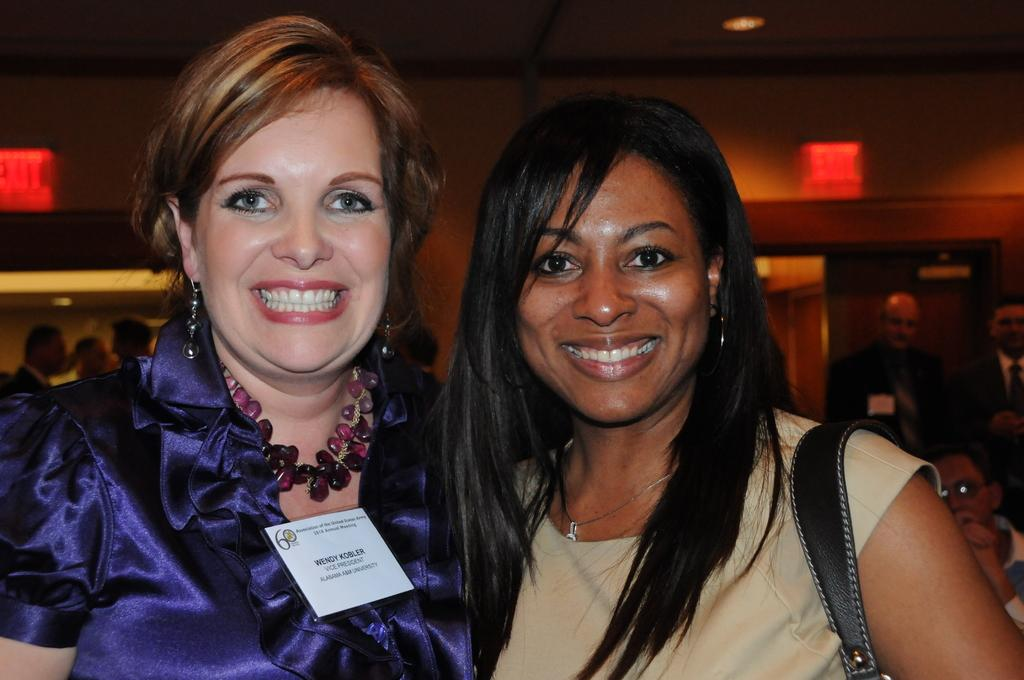How many women are in the image? There are two women in the image. What are the women doing in the image? The women are smiling and posing for the camera. Can you describe the people in the background of the image? There are other people visible in the background of the image. What type of rat can be seen in the image? There is no rat present in the image. Can you tell me the name of the mom in the image? The provided facts do not mention any mothers or names, so it cannot be determined from the image. 